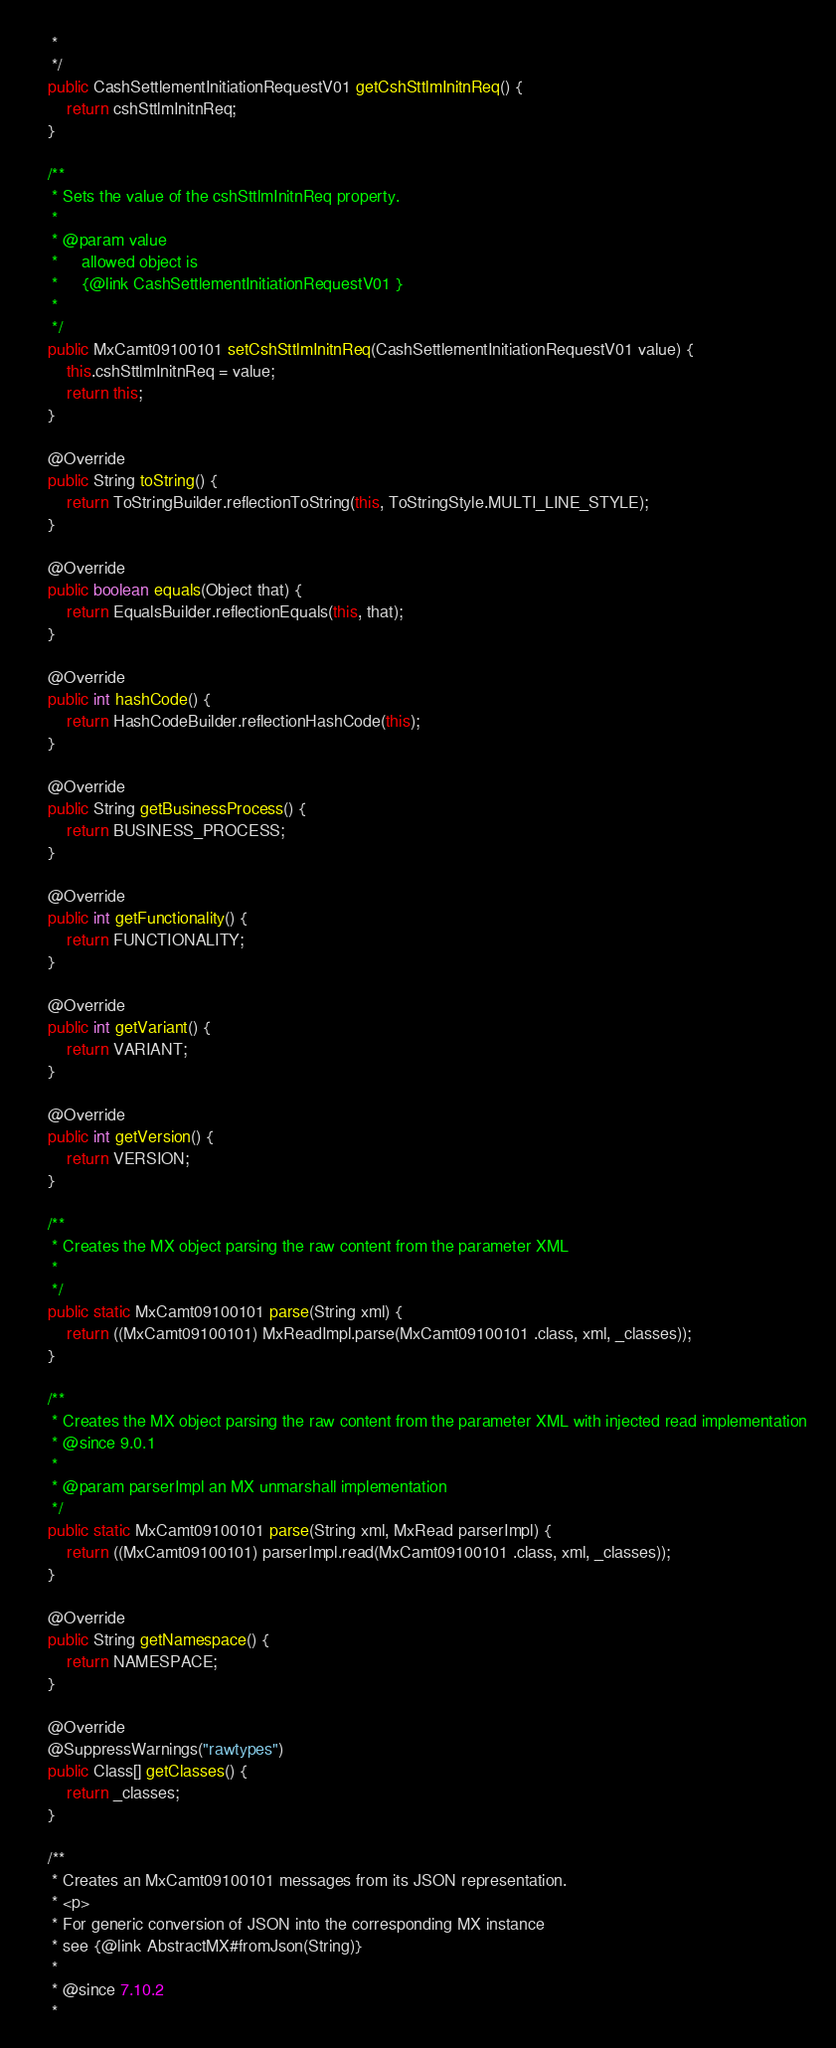Convert code to text. <code><loc_0><loc_0><loc_500><loc_500><_Java_>     *     
     */
    public CashSettlementInitiationRequestV01 getCshSttlmInitnReq() {
        return cshSttlmInitnReq;
    }

    /**
     * Sets the value of the cshSttlmInitnReq property.
     * 
     * @param value
     *     allowed object is
     *     {@link CashSettlementInitiationRequestV01 }
     *     
     */
    public MxCamt09100101 setCshSttlmInitnReq(CashSettlementInitiationRequestV01 value) {
        this.cshSttlmInitnReq = value;
        return this;
    }

    @Override
    public String toString() {
        return ToStringBuilder.reflectionToString(this, ToStringStyle.MULTI_LINE_STYLE);
    }

    @Override
    public boolean equals(Object that) {
        return EqualsBuilder.reflectionEquals(this, that);
    }

    @Override
    public int hashCode() {
        return HashCodeBuilder.reflectionHashCode(this);
    }

    @Override
    public String getBusinessProcess() {
        return BUSINESS_PROCESS;
    }

    @Override
    public int getFunctionality() {
        return FUNCTIONALITY;
    }

    @Override
    public int getVariant() {
        return VARIANT;
    }

    @Override
    public int getVersion() {
        return VERSION;
    }

    /**
     * Creates the MX object parsing the raw content from the parameter XML
     * 
     */
    public static MxCamt09100101 parse(String xml) {
        return ((MxCamt09100101) MxReadImpl.parse(MxCamt09100101 .class, xml, _classes));
    }

    /**
     * Creates the MX object parsing the raw content from the parameter XML with injected read implementation
     * @since 9.0.1
     * 
     * @param parserImpl an MX unmarshall implementation
     */
    public static MxCamt09100101 parse(String xml, MxRead parserImpl) {
        return ((MxCamt09100101) parserImpl.read(MxCamt09100101 .class, xml, _classes));
    }

    @Override
    public String getNamespace() {
        return NAMESPACE;
    }

    @Override
    @SuppressWarnings("rawtypes")
    public Class[] getClasses() {
        return _classes;
    }

    /**
     * Creates an MxCamt09100101 messages from its JSON representation.
     * <p>
     * For generic conversion of JSON into the corresponding MX instance 
     * see {@link AbstractMX#fromJson(String)}
     * 
     * @since 7.10.2
     * </code> 